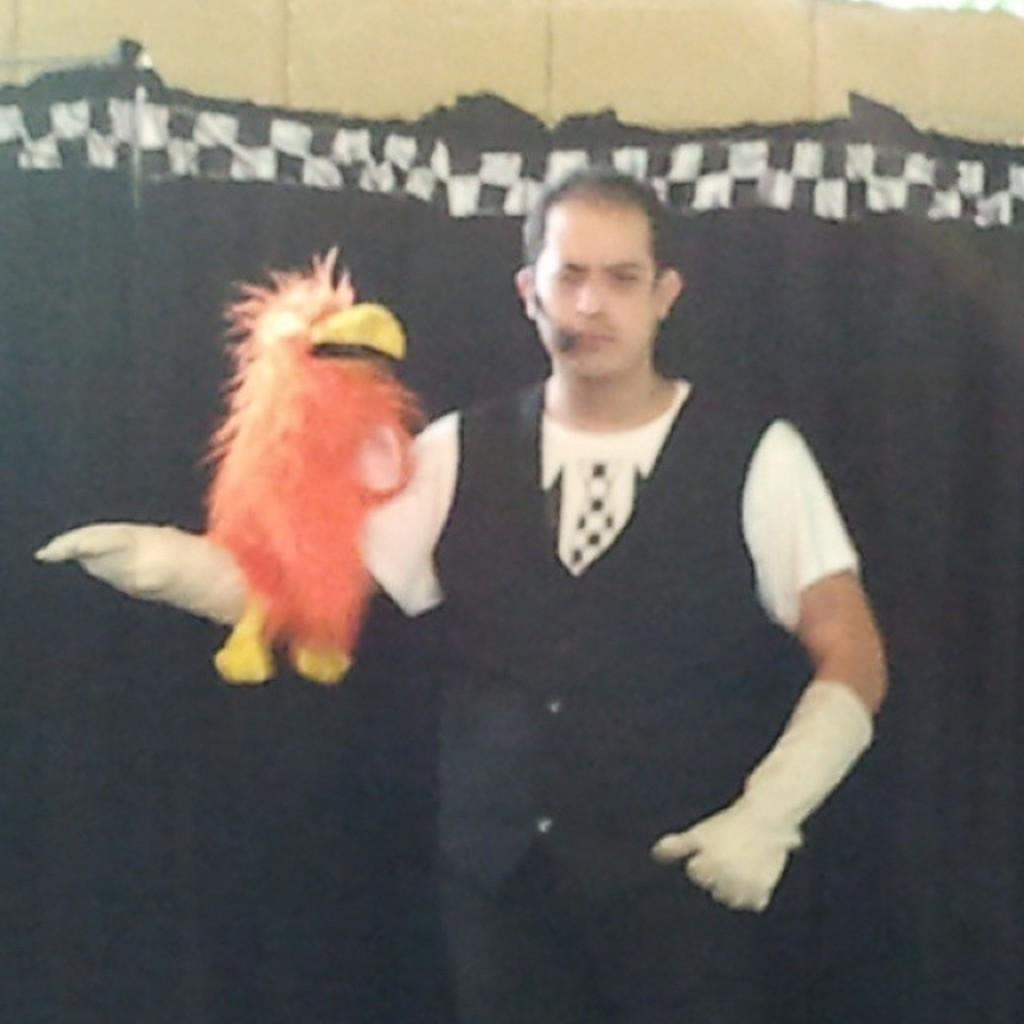What is the main subject of the image? There is a man in the image. What is the man holding in his hand? The man is holding a puppet in his hand. Can you describe the background of the image? There is a black color curtain in the background of the image. Can you tell me how deep the river is in the image? There is no river present in the image; it features a man holding a puppet in front of a black curtain. 